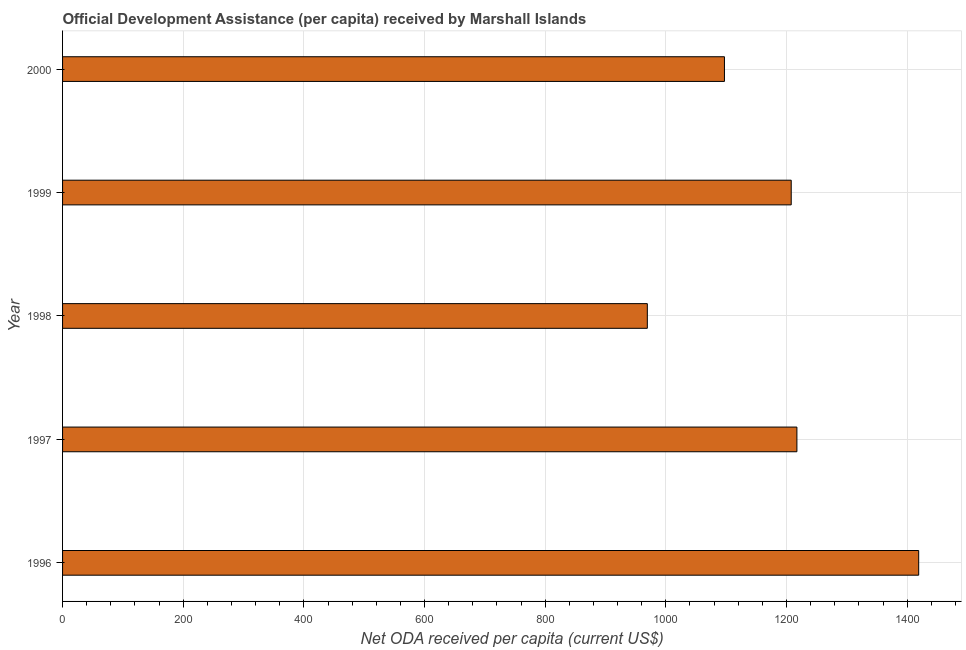Does the graph contain grids?
Give a very brief answer. Yes. What is the title of the graph?
Ensure brevity in your answer.  Official Development Assistance (per capita) received by Marshall Islands. What is the label or title of the X-axis?
Keep it short and to the point. Net ODA received per capita (current US$). What is the net oda received per capita in 1997?
Ensure brevity in your answer.  1217.29. Across all years, what is the maximum net oda received per capita?
Your answer should be very brief. 1419.15. Across all years, what is the minimum net oda received per capita?
Your answer should be compact. 969.34. In which year was the net oda received per capita maximum?
Give a very brief answer. 1996. In which year was the net oda received per capita minimum?
Provide a short and direct response. 1998. What is the sum of the net oda received per capita?
Your answer should be compact. 5910.8. What is the difference between the net oda received per capita in 1997 and 1998?
Offer a very short reply. 247.95. What is the average net oda received per capita per year?
Give a very brief answer. 1182.16. What is the median net oda received per capita?
Keep it short and to the point. 1207.85. In how many years, is the net oda received per capita greater than 1400 US$?
Ensure brevity in your answer.  1. What is the ratio of the net oda received per capita in 1997 to that in 1998?
Ensure brevity in your answer.  1.26. What is the difference between the highest and the second highest net oda received per capita?
Make the answer very short. 201.86. What is the difference between the highest and the lowest net oda received per capita?
Keep it short and to the point. 449.81. How many years are there in the graph?
Make the answer very short. 5. What is the Net ODA received per capita (current US$) of 1996?
Make the answer very short. 1419.15. What is the Net ODA received per capita (current US$) of 1997?
Make the answer very short. 1217.29. What is the Net ODA received per capita (current US$) in 1998?
Your answer should be very brief. 969.34. What is the Net ODA received per capita (current US$) in 1999?
Make the answer very short. 1207.85. What is the Net ODA received per capita (current US$) of 2000?
Make the answer very short. 1097.18. What is the difference between the Net ODA received per capita (current US$) in 1996 and 1997?
Offer a very short reply. 201.86. What is the difference between the Net ODA received per capita (current US$) in 1996 and 1998?
Your answer should be compact. 449.81. What is the difference between the Net ODA received per capita (current US$) in 1996 and 1999?
Make the answer very short. 211.3. What is the difference between the Net ODA received per capita (current US$) in 1996 and 2000?
Offer a very short reply. 321.97. What is the difference between the Net ODA received per capita (current US$) in 1997 and 1998?
Your response must be concise. 247.95. What is the difference between the Net ODA received per capita (current US$) in 1997 and 1999?
Make the answer very short. 9.44. What is the difference between the Net ODA received per capita (current US$) in 1997 and 2000?
Provide a succinct answer. 120.11. What is the difference between the Net ODA received per capita (current US$) in 1998 and 1999?
Keep it short and to the point. -238.51. What is the difference between the Net ODA received per capita (current US$) in 1998 and 2000?
Keep it short and to the point. -127.84. What is the difference between the Net ODA received per capita (current US$) in 1999 and 2000?
Give a very brief answer. 110.67. What is the ratio of the Net ODA received per capita (current US$) in 1996 to that in 1997?
Provide a short and direct response. 1.17. What is the ratio of the Net ODA received per capita (current US$) in 1996 to that in 1998?
Provide a succinct answer. 1.46. What is the ratio of the Net ODA received per capita (current US$) in 1996 to that in 1999?
Make the answer very short. 1.18. What is the ratio of the Net ODA received per capita (current US$) in 1996 to that in 2000?
Your answer should be very brief. 1.29. What is the ratio of the Net ODA received per capita (current US$) in 1997 to that in 1998?
Your answer should be compact. 1.26. What is the ratio of the Net ODA received per capita (current US$) in 1997 to that in 2000?
Offer a very short reply. 1.11. What is the ratio of the Net ODA received per capita (current US$) in 1998 to that in 1999?
Your answer should be very brief. 0.8. What is the ratio of the Net ODA received per capita (current US$) in 1998 to that in 2000?
Give a very brief answer. 0.88. What is the ratio of the Net ODA received per capita (current US$) in 1999 to that in 2000?
Make the answer very short. 1.1. 